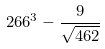<formula> <loc_0><loc_0><loc_500><loc_500>2 6 6 ^ { 3 } - \frac { 9 } { \sqrt { 4 6 2 } }</formula> 